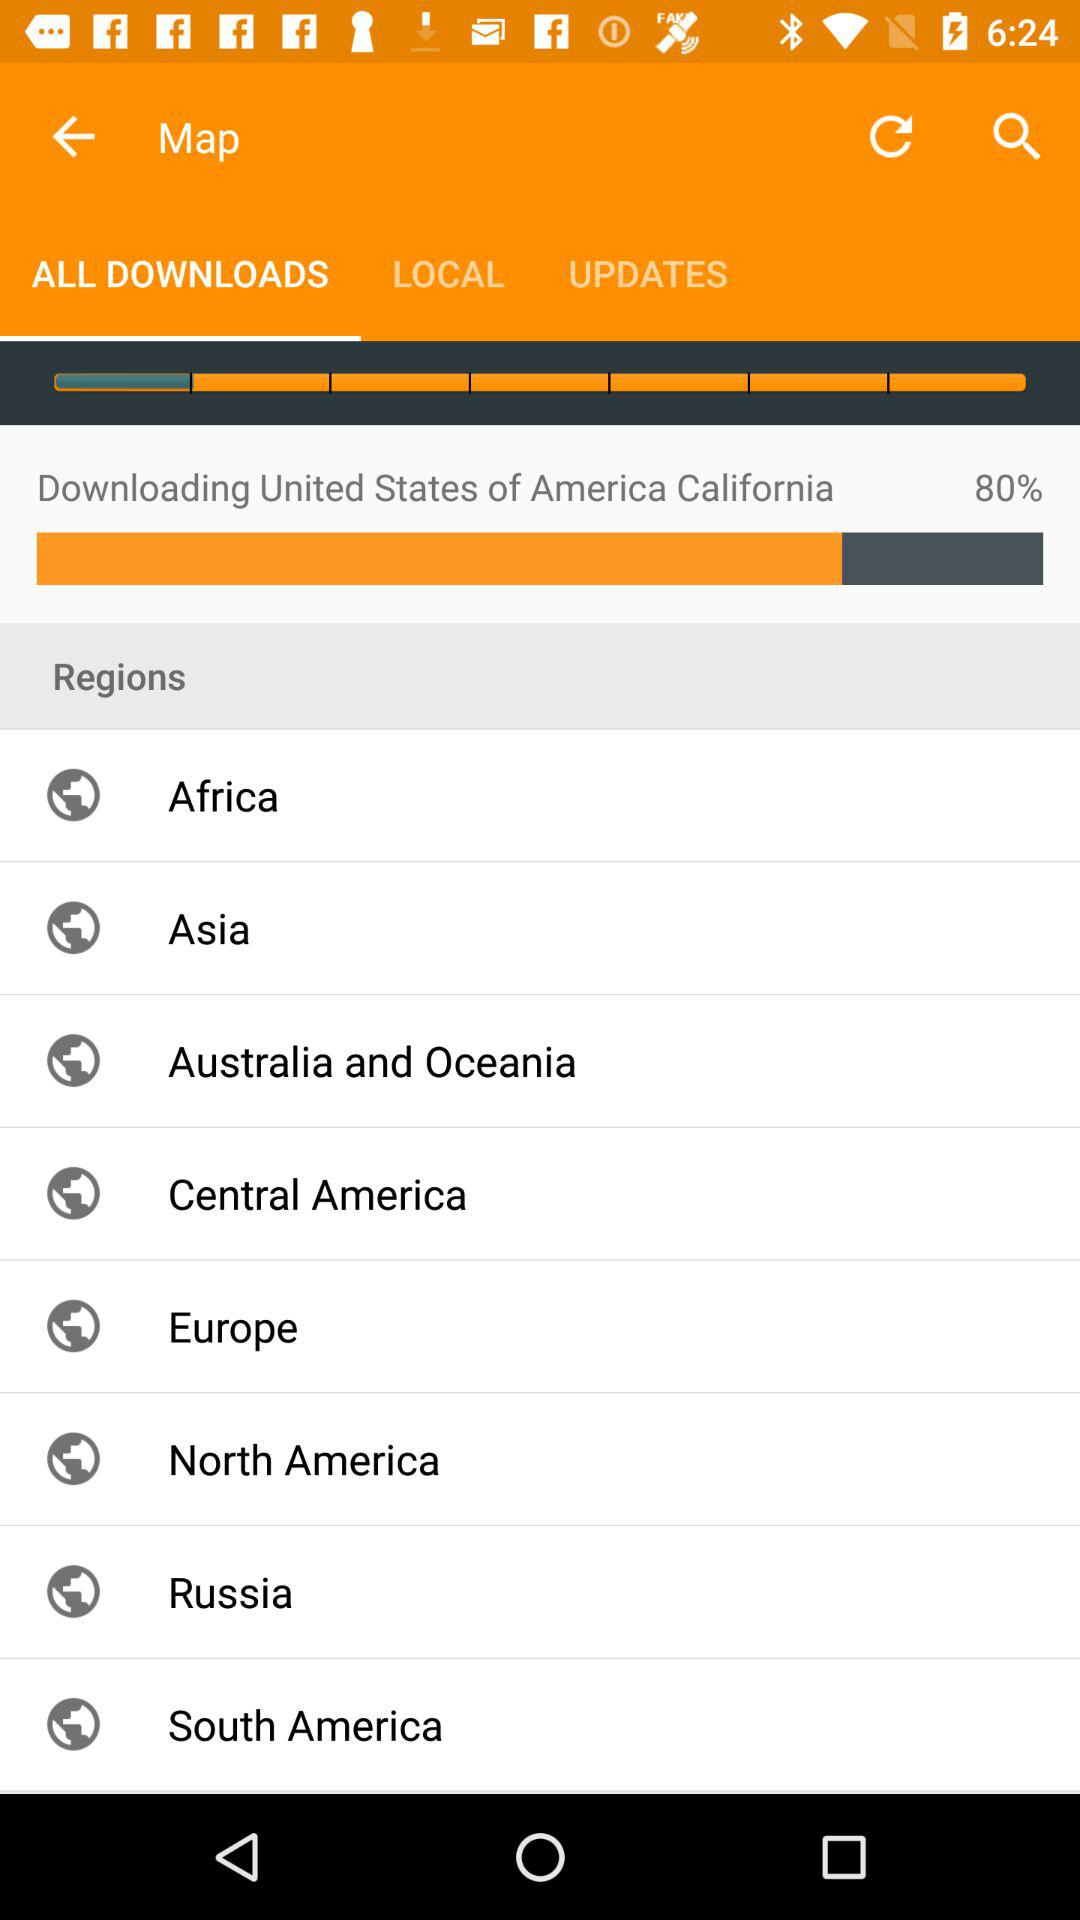What is the percentage of completion?
Answer the question using a single word or phrase. 80% 